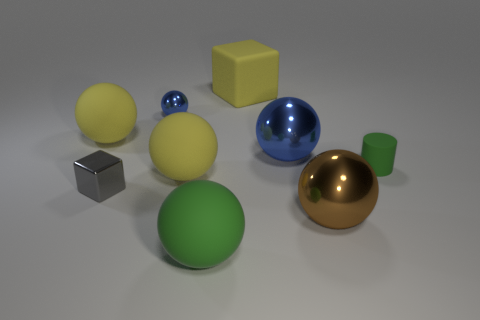Is the number of small shiny balls greater than the number of purple rubber objects?
Provide a succinct answer. Yes. What number of objects are matte balls behind the tiny green matte cylinder or yellow matte blocks?
Make the answer very short. 2. Are the small blue thing and the tiny gray block made of the same material?
Provide a succinct answer. Yes. The yellow object that is the same shape as the gray shiny thing is what size?
Keep it short and to the point. Large. Do the large matte thing in front of the tiny gray thing and the blue object on the left side of the big yellow rubber cube have the same shape?
Give a very brief answer. Yes. Do the yellow matte block and the brown metallic ball that is in front of the tiny green matte cylinder have the same size?
Provide a succinct answer. Yes. How many other objects are the same material as the tiny gray thing?
Provide a succinct answer. 3. Is there anything else that has the same shape as the tiny gray thing?
Ensure brevity in your answer.  Yes. There is a rubber object behind the yellow ball that is behind the blue ball that is on the right side of the tiny shiny ball; what is its color?
Ensure brevity in your answer.  Yellow. What is the shape of the object that is both to the right of the big green matte object and in front of the tiny cylinder?
Provide a succinct answer. Sphere. 